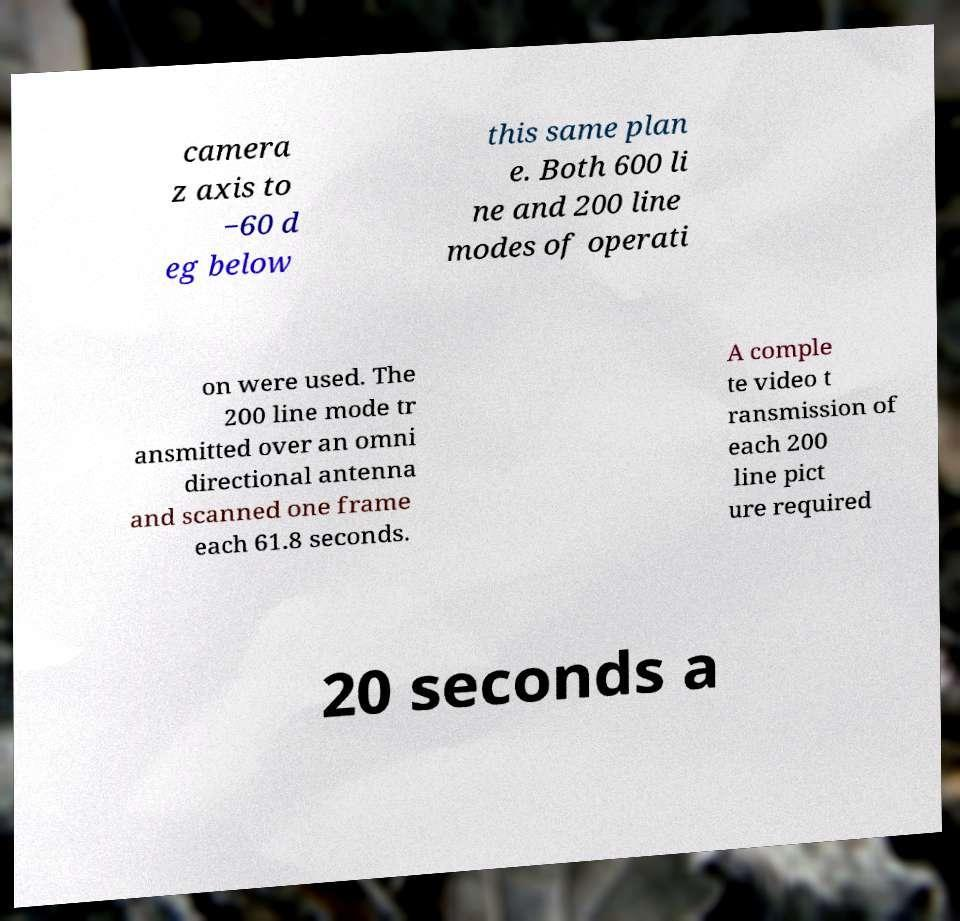For documentation purposes, I need the text within this image transcribed. Could you provide that? camera z axis to −60 d eg below this same plan e. Both 600 li ne and 200 line modes of operati on were used. The 200 line mode tr ansmitted over an omni directional antenna and scanned one frame each 61.8 seconds. A comple te video t ransmission of each 200 line pict ure required 20 seconds a 